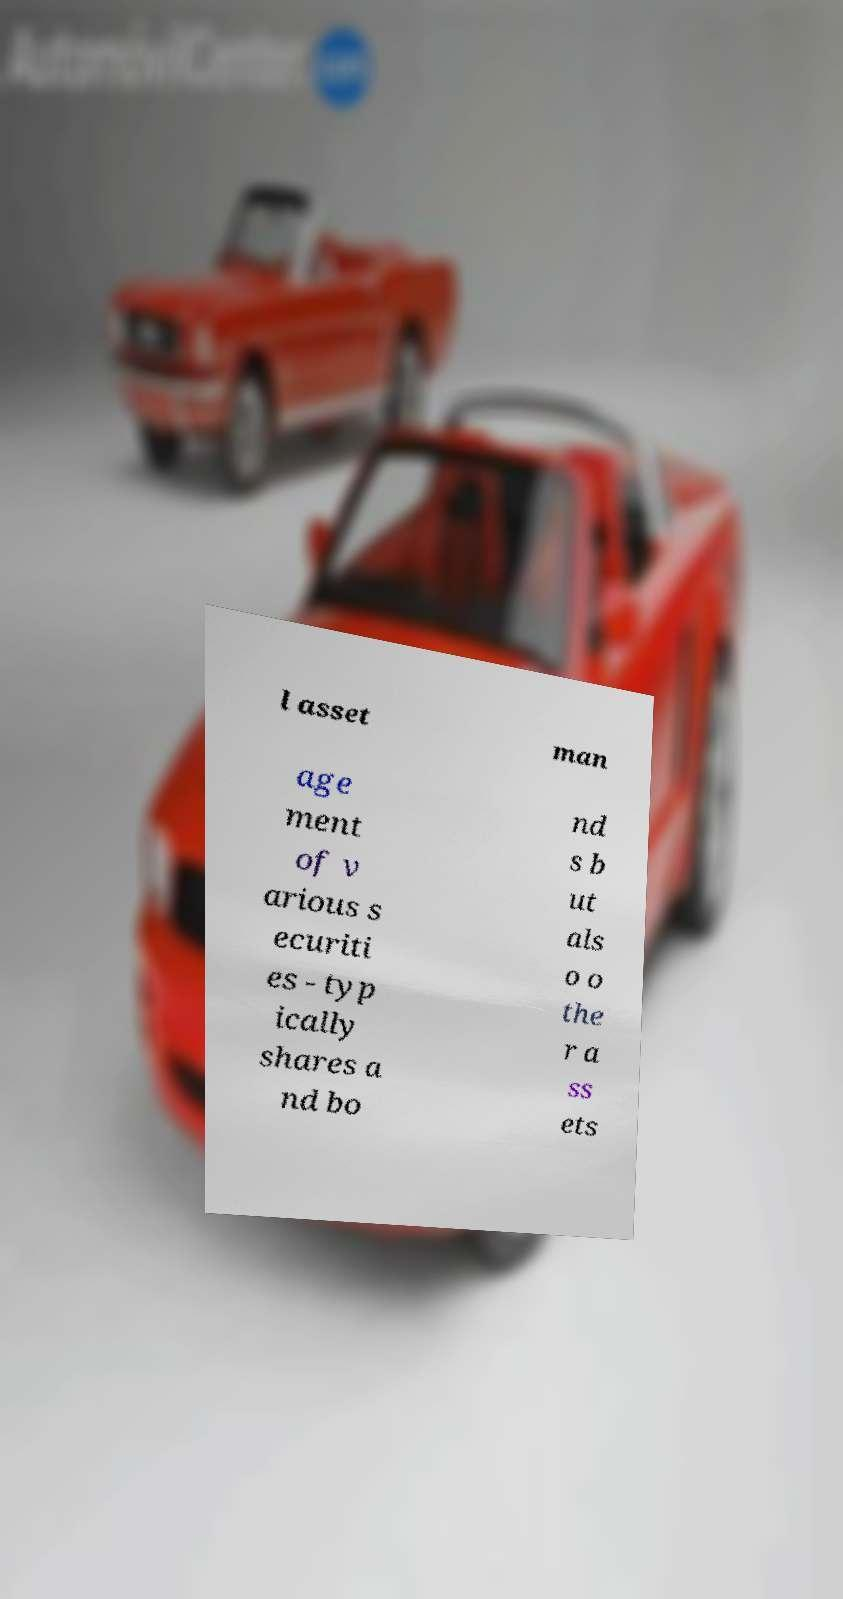Please identify and transcribe the text found in this image. l asset man age ment of v arious s ecuriti es - typ ically shares a nd bo nd s b ut als o o the r a ss ets 